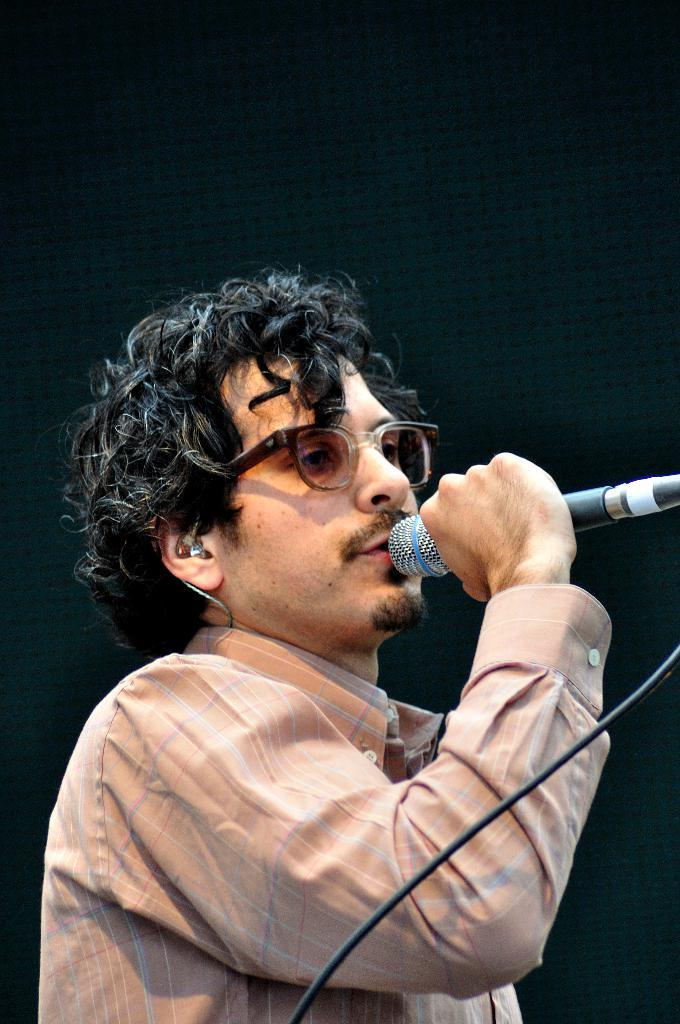What is the main subject of the image? There is a man in the image. What is the man wearing? The man is wearing a cream color shirt. What is the man holding in the image? The man is holding a mic. What can be seen in the background of the image? The background of the image is black. What might the man be doing in the image? It appears that the man is singing. Can you see any mountains in the background of the image? There are no mountains visible in the background of the image; it is black. What part of the man's body is marked with a tattoo? There is no information about any tattoos on the man's body in the provided facts. 